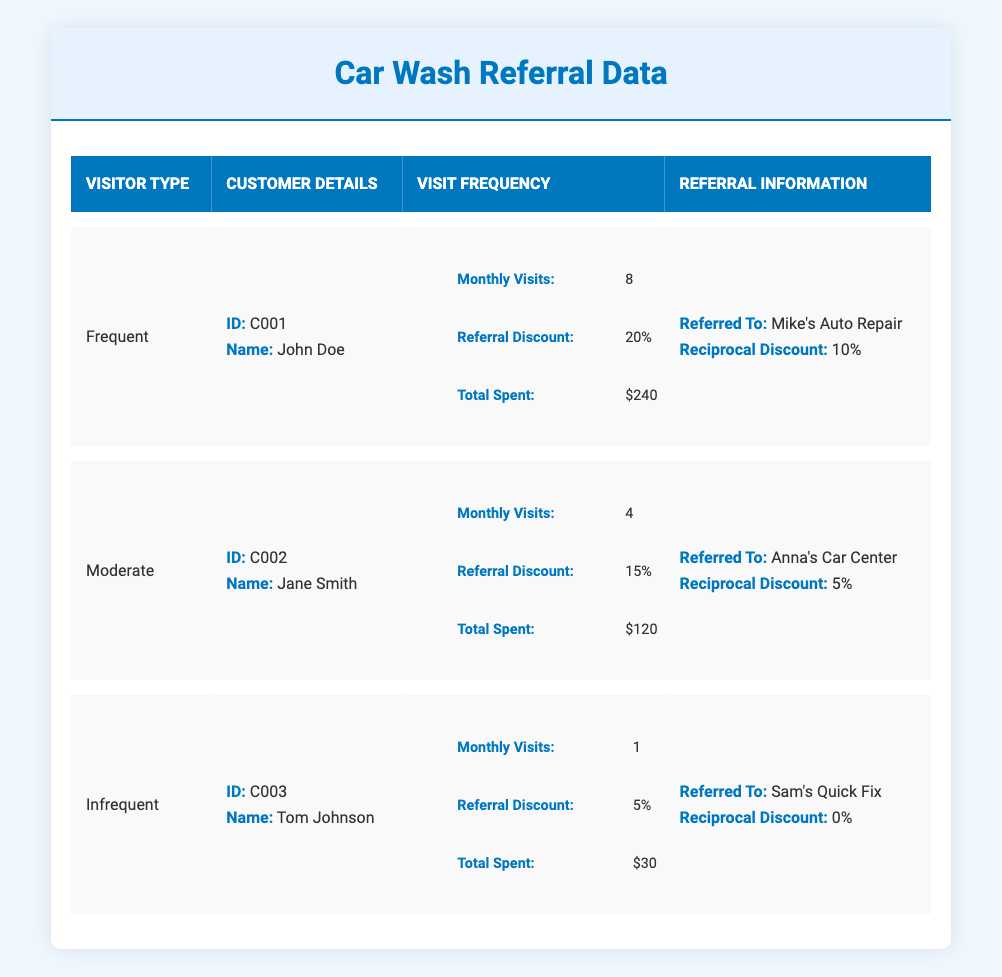What is the total amount spent by the frequent visitor, John Doe? John Doe has a total spent amount listed under the "Total Spent" section in the table for frequent visitors, which is $240.
Answer: $240 What is the referral discount offered to moderate visitors? The referral discount for moderate visitors, specifically for Jane Smith, is located in the "Referral Information" section and is indicated as 15%.
Answer: 15% Which garage owner did Tom Johnson refer to? The table states that Tom Johnson, categorized as an infrequent visitor, referred to "Sam's Quick Fix" as indicated in his "Referral Information."
Answer: Sam's Quick Fix Is the reciprocal discount offered to John Doe higher than that for Jane Smith? John Doe's reciprocal discount is 10%, while Jane Smith's reciprocal discount is 5%. Since 10% is greater than 5%, the answer is yes.
Answer: Yes What is the average monthly visit frequency among the three customer types? There are three customers with visit frequencies of 8 (John), 4 (Jane), and 1 (Tom). The sum is 8 + 4 + 1 = 13. There are 3 customers, so the average is 13/3, which equals approximately 4.33.
Answer: 4.33 How much total did moderate visitors spend compared to infrequent visitors? The total spent by moderate visitor Jane Smith is $120 and infrequent visitor Tom Johnson is $30. The difference is calculated as $120 - $30 = $90, indicating moderate visitors spent $90 more.
Answer: $90 Does Tom Johnson receive any reciprocal discounts for his referral? The table indicates that Tom Johnson received a reciprocal discount of 0%, meaning he does not receive any discounts in return for his referral.
Answer: No Which visitor has the highest monthly visits? By comparing the monthly visits across all three customers, John Doe (frequent) has 8 visits, Jane Smith (moderate) has 4 visits, and Tom Johnson (infrequent) has 1 visit. John Doe has the highest visits.
Answer: John Doe 